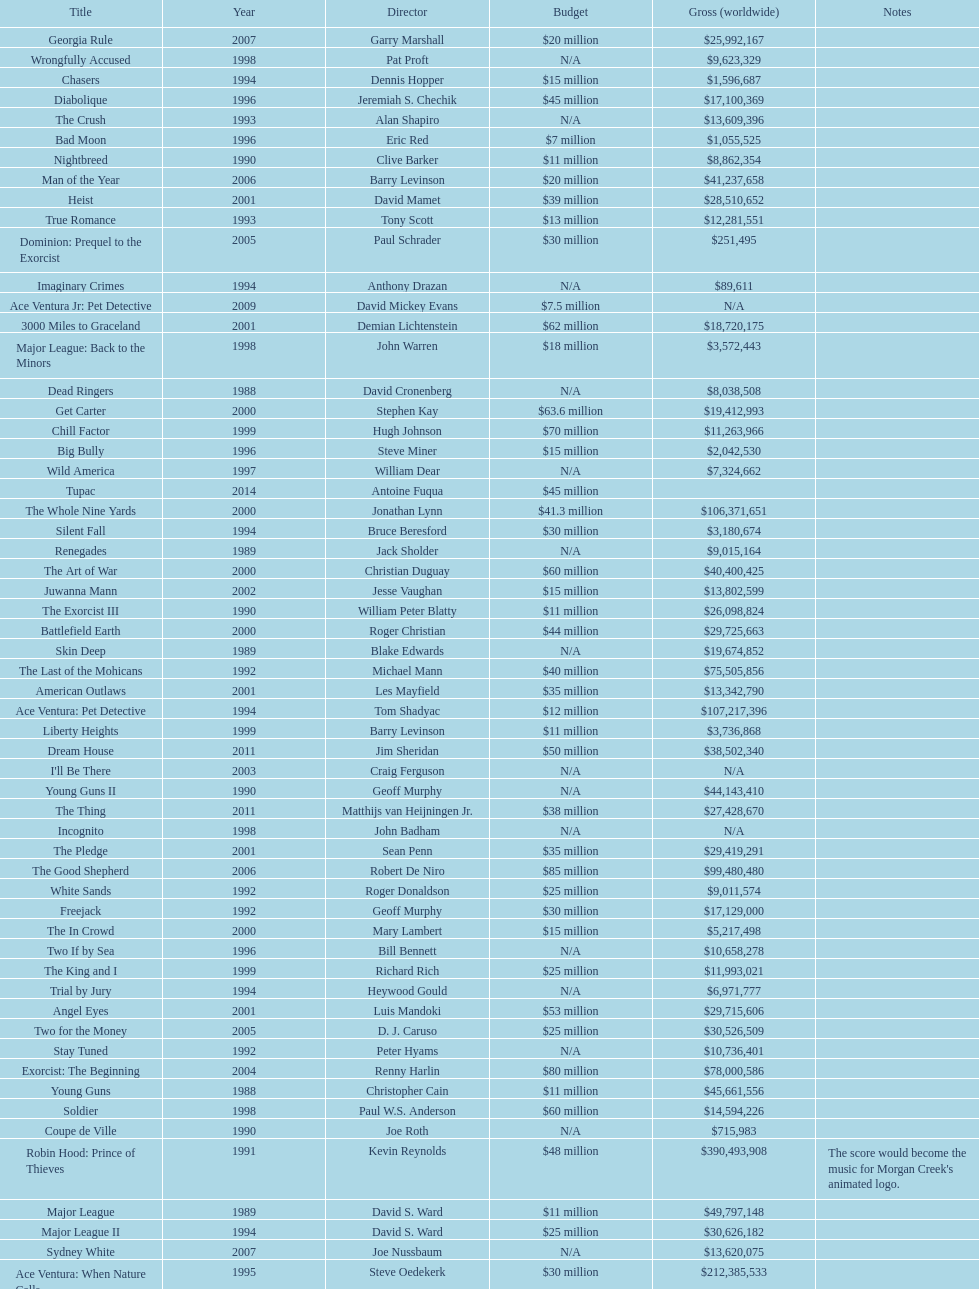Which morgan creek film grossed the most money prior to 1994? Robin Hood: Prince of Thieves. 